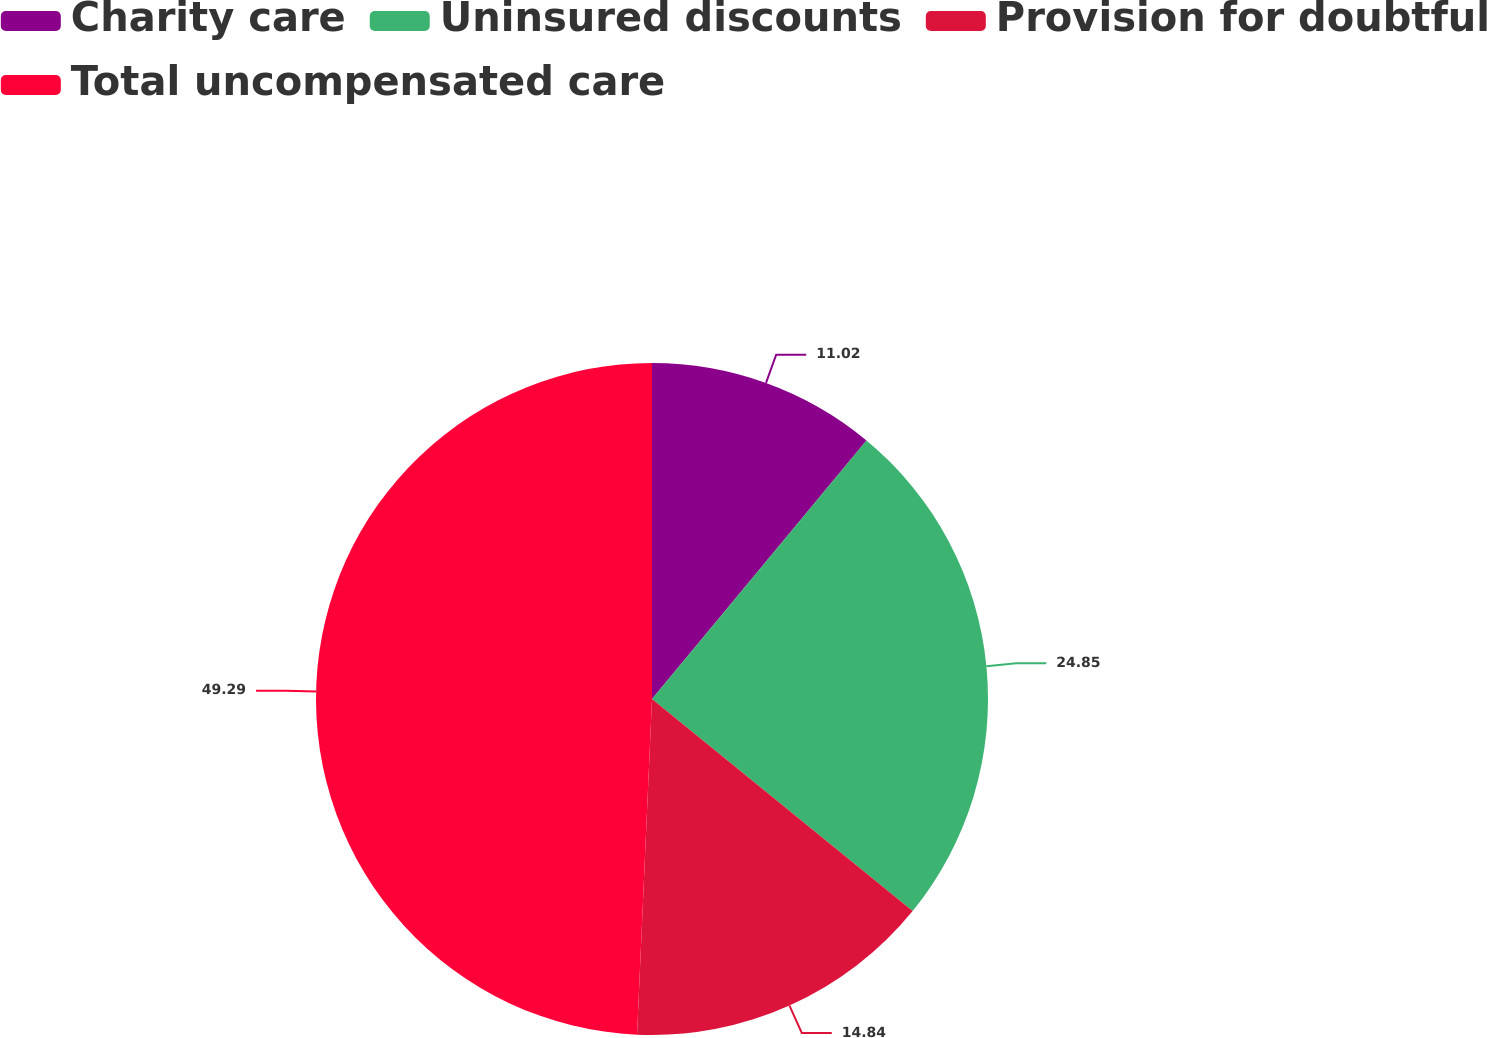Convert chart. <chart><loc_0><loc_0><loc_500><loc_500><pie_chart><fcel>Charity care<fcel>Uninsured discounts<fcel>Provision for doubtful<fcel>Total uncompensated care<nl><fcel>11.02%<fcel>24.85%<fcel>14.84%<fcel>49.29%<nl></chart> 